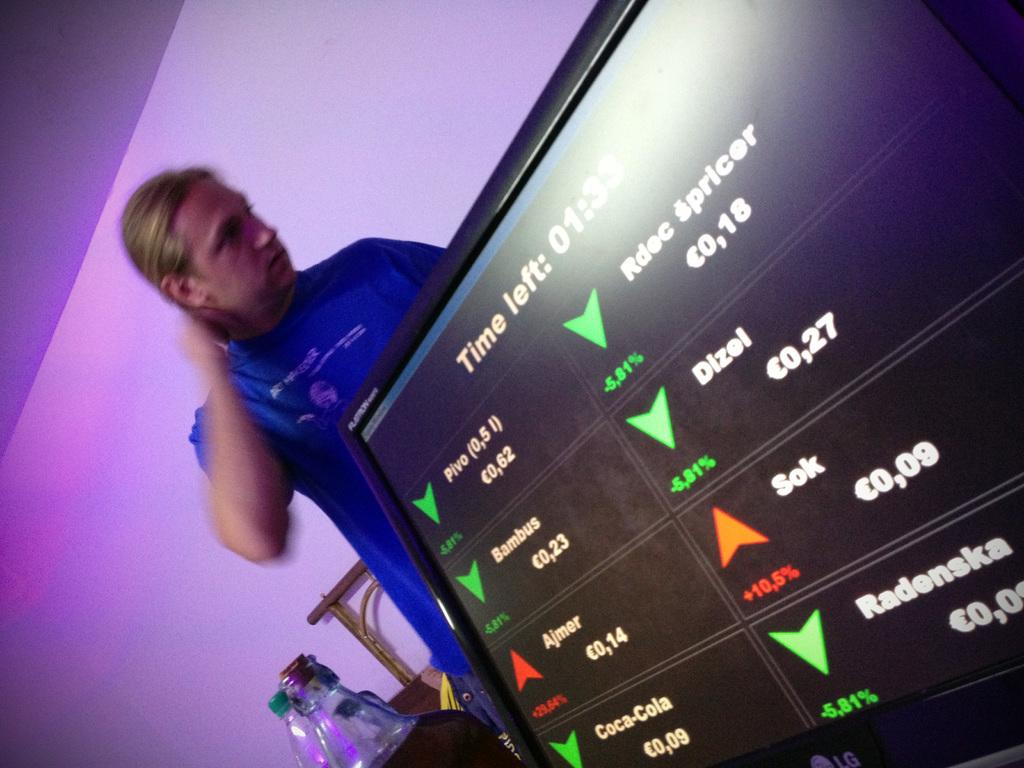<image>
Relay a brief, clear account of the picture shown. A man stands behind a display that shows there is 1:33 time remaining. 